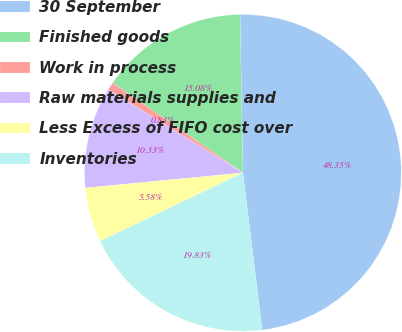Convert chart to OTSL. <chart><loc_0><loc_0><loc_500><loc_500><pie_chart><fcel>30 September<fcel>Finished goods<fcel>Work in process<fcel>Raw materials supplies and<fcel>Less Excess of FIFO cost over<fcel>Inventories<nl><fcel>48.35%<fcel>15.08%<fcel>0.83%<fcel>10.33%<fcel>5.58%<fcel>19.83%<nl></chart> 